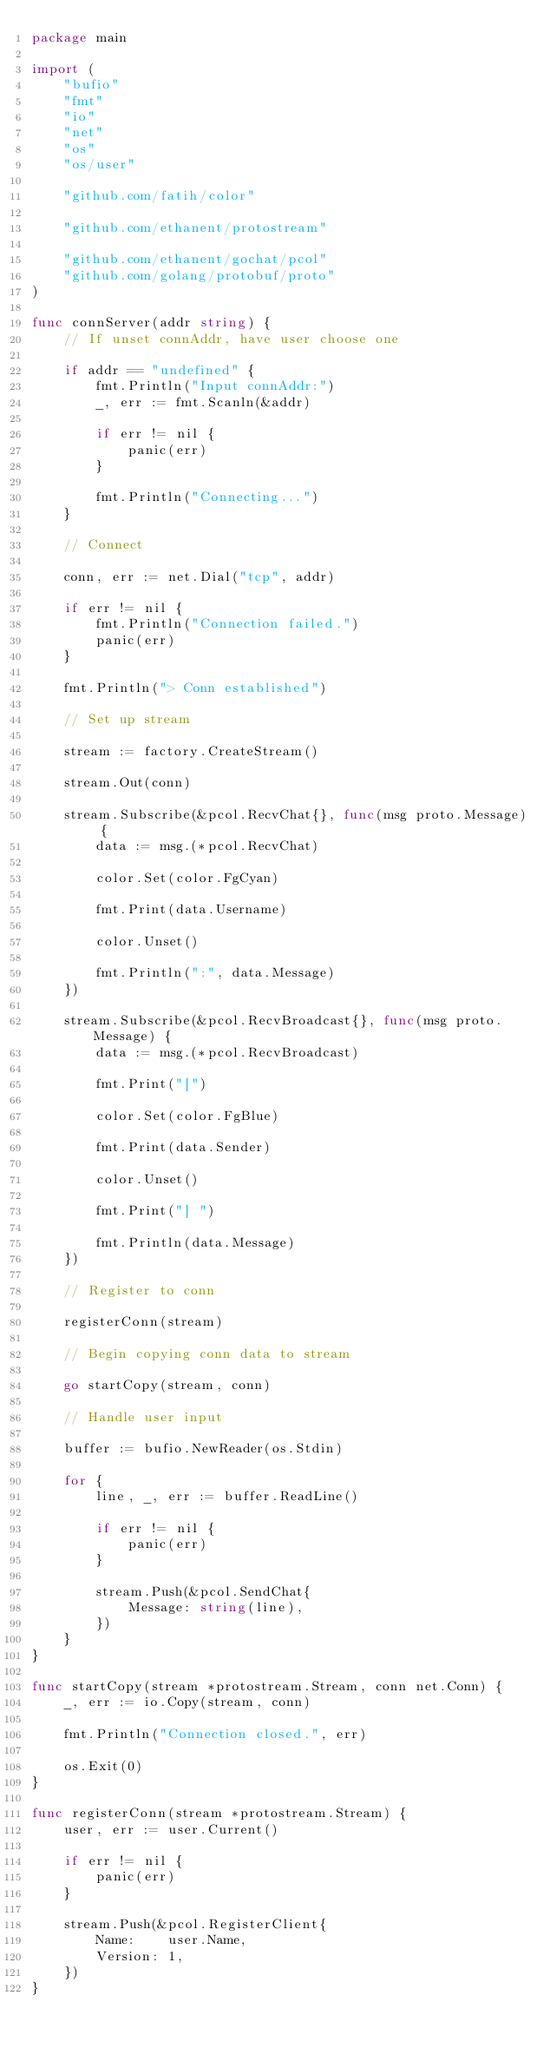<code> <loc_0><loc_0><loc_500><loc_500><_Go_>package main

import (
	"bufio"
	"fmt"
	"io"
	"net"
	"os"
	"os/user"

	"github.com/fatih/color"

	"github.com/ethanent/protostream"

	"github.com/ethanent/gochat/pcol"
	"github.com/golang/protobuf/proto"
)

func connServer(addr string) {
	// If unset connAddr, have user choose one

	if addr == "undefined" {
		fmt.Println("Input connAddr:")
		_, err := fmt.Scanln(&addr)

		if err != nil {
			panic(err)
		}

		fmt.Println("Connecting...")
	}

	// Connect

	conn, err := net.Dial("tcp", addr)

	if err != nil {
		fmt.Println("Connection failed.")
		panic(err)
	}

	fmt.Println("> Conn established")

	// Set up stream

	stream := factory.CreateStream()

	stream.Out(conn)

	stream.Subscribe(&pcol.RecvChat{}, func(msg proto.Message) {
		data := msg.(*pcol.RecvChat)

		color.Set(color.FgCyan)

		fmt.Print(data.Username)

		color.Unset()

		fmt.Println(":", data.Message)
	})

	stream.Subscribe(&pcol.RecvBroadcast{}, func(msg proto.Message) {
		data := msg.(*pcol.RecvBroadcast)

		fmt.Print("[")

		color.Set(color.FgBlue)

		fmt.Print(data.Sender)

		color.Unset()

		fmt.Print("] ")

		fmt.Println(data.Message)
	})

	// Register to conn

	registerConn(stream)

	// Begin copying conn data to stream

	go startCopy(stream, conn)

	// Handle user input

	buffer := bufio.NewReader(os.Stdin)

	for {
		line, _, err := buffer.ReadLine()

		if err != nil {
			panic(err)
		}

		stream.Push(&pcol.SendChat{
			Message: string(line),
		})
	}
}

func startCopy(stream *protostream.Stream, conn net.Conn) {
	_, err := io.Copy(stream, conn)

	fmt.Println("Connection closed.", err)

	os.Exit(0)
}

func registerConn(stream *protostream.Stream) {
	user, err := user.Current()

	if err != nil {
		panic(err)
	}

	stream.Push(&pcol.RegisterClient{
		Name:    user.Name,
		Version: 1,
	})
}
</code> 